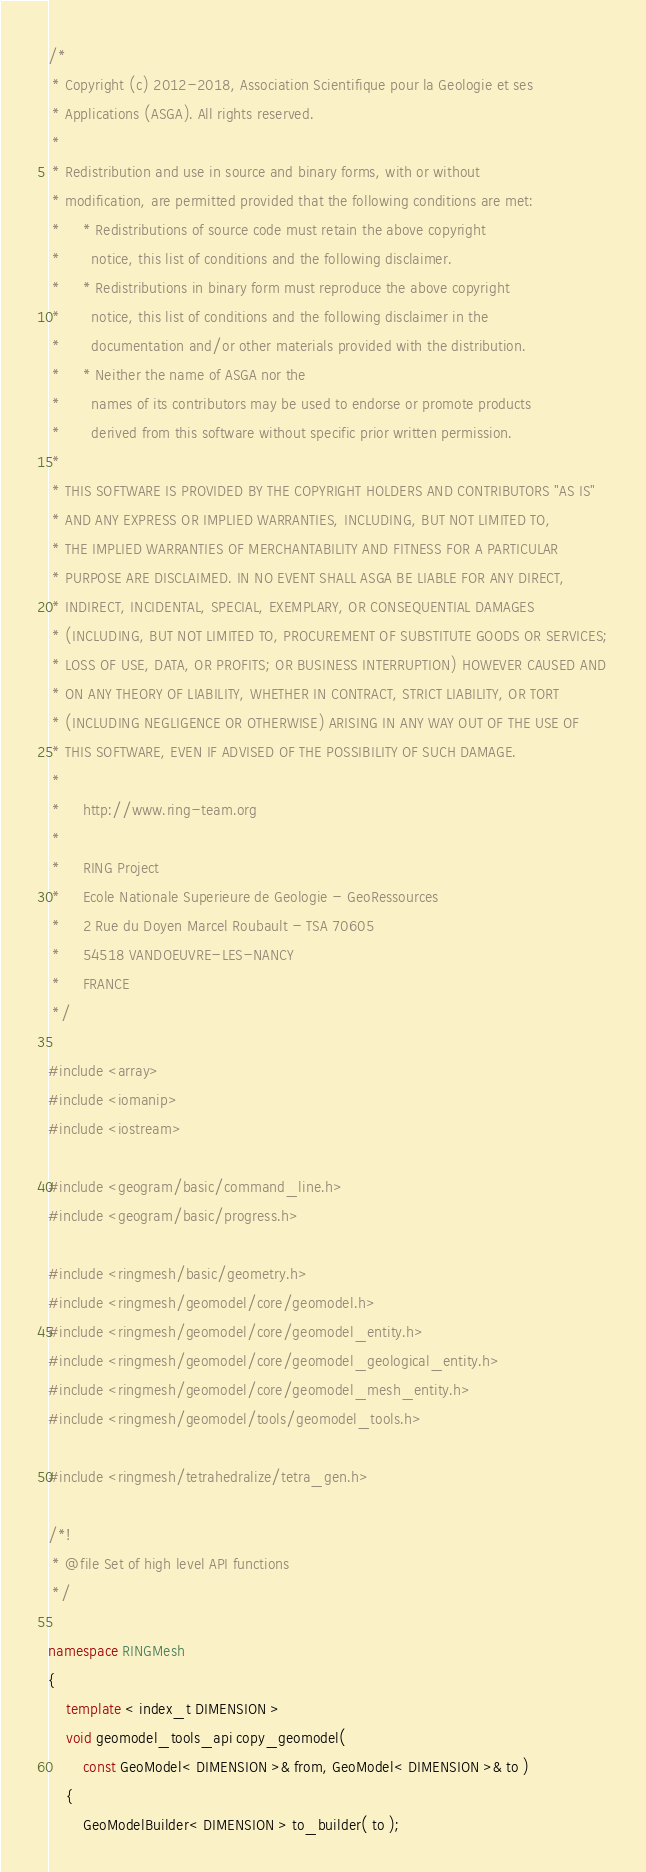<code> <loc_0><loc_0><loc_500><loc_500><_C++_>/*
 * Copyright (c) 2012-2018, Association Scientifique pour la Geologie et ses
 * Applications (ASGA). All rights reserved.
 *
 * Redistribution and use in source and binary forms, with or without
 * modification, are permitted provided that the following conditions are met:
 *     * Redistributions of source code must retain the above copyright
 *       notice, this list of conditions and the following disclaimer.
 *     * Redistributions in binary form must reproduce the above copyright
 *       notice, this list of conditions and the following disclaimer in the
 *       documentation and/or other materials provided with the distribution.
 *     * Neither the name of ASGA nor the
 *       names of its contributors may be used to endorse or promote products
 *       derived from this software without specific prior written permission.
 *
 * THIS SOFTWARE IS PROVIDED BY THE COPYRIGHT HOLDERS AND CONTRIBUTORS "AS IS"
 * AND ANY EXPRESS OR IMPLIED WARRANTIES, INCLUDING, BUT NOT LIMITED TO,
 * THE IMPLIED WARRANTIES OF MERCHANTABILITY AND FITNESS FOR A PARTICULAR
 * PURPOSE ARE DISCLAIMED. IN NO EVENT SHALL ASGA BE LIABLE FOR ANY DIRECT,
 * INDIRECT, INCIDENTAL, SPECIAL, EXEMPLARY, OR CONSEQUENTIAL DAMAGES
 * (INCLUDING, BUT NOT LIMITED TO, PROCUREMENT OF SUBSTITUTE GOODS OR SERVICES;
 * LOSS OF USE, DATA, OR PROFITS; OR BUSINESS INTERRUPTION) HOWEVER CAUSED AND
 * ON ANY THEORY OF LIABILITY, WHETHER IN CONTRACT, STRICT LIABILITY, OR TORT
 * (INCLUDING NEGLIGENCE OR OTHERWISE) ARISING IN ANY WAY OUT OF THE USE OF
 * THIS SOFTWARE, EVEN IF ADVISED OF THE POSSIBILITY OF SUCH DAMAGE.
 *
 *     http://www.ring-team.org
 *
 *     RING Project
 *     Ecole Nationale Superieure de Geologie - GeoRessources
 *     2 Rue du Doyen Marcel Roubault - TSA 70605
 *     54518 VANDOEUVRE-LES-NANCY
 *     FRANCE
 */

#include <array>
#include <iomanip>
#include <iostream>

#include <geogram/basic/command_line.h>
#include <geogram/basic/progress.h>

#include <ringmesh/basic/geometry.h>
#include <ringmesh/geomodel/core/geomodel.h>
#include <ringmesh/geomodel/core/geomodel_entity.h>
#include <ringmesh/geomodel/core/geomodel_geological_entity.h>
#include <ringmesh/geomodel/core/geomodel_mesh_entity.h>
#include <ringmesh/geomodel/tools/geomodel_tools.h>

#include <ringmesh/tetrahedralize/tetra_gen.h>

/*!
 * @file Set of high level API functions
 */

namespace RINGMesh
{
    template < index_t DIMENSION >
    void geomodel_tools_api copy_geomodel(
        const GeoModel< DIMENSION >& from, GeoModel< DIMENSION >& to )
    {
        GeoModelBuilder< DIMENSION > to_builder( to );</code> 